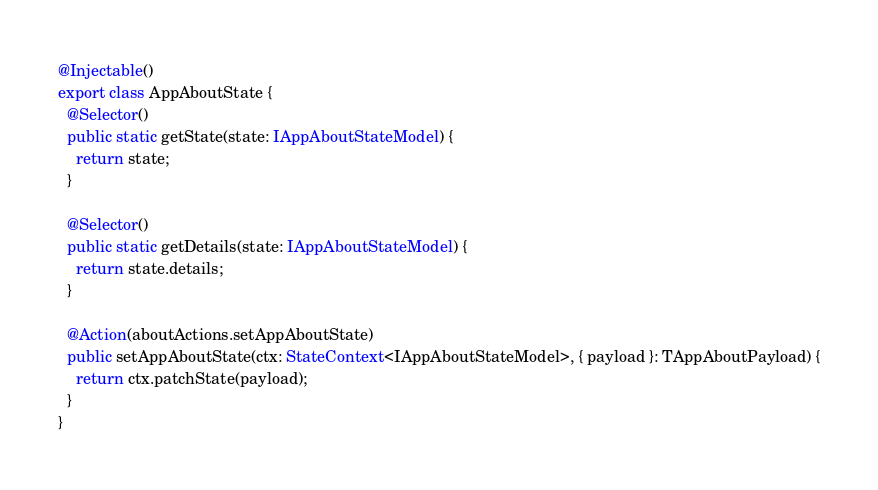Convert code to text. <code><loc_0><loc_0><loc_500><loc_500><_TypeScript_>@Injectable()
export class AppAboutState {
  @Selector()
  public static getState(state: IAppAboutStateModel) {
    return state;
  }

  @Selector()
  public static getDetails(state: IAppAboutStateModel) {
    return state.details;
  }

  @Action(aboutActions.setAppAboutState)
  public setAppAboutState(ctx: StateContext<IAppAboutStateModel>, { payload }: TAppAboutPayload) {
    return ctx.patchState(payload);
  }
}
</code> 